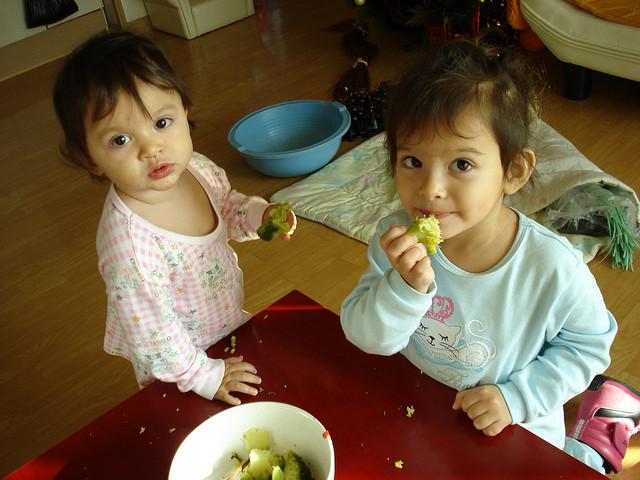Is the table messy?
Write a very short answer. Yes. Do these kids like fruit?
Short answer required. Yes. What are the kids eating?
Give a very brief answer. Broccoli. 